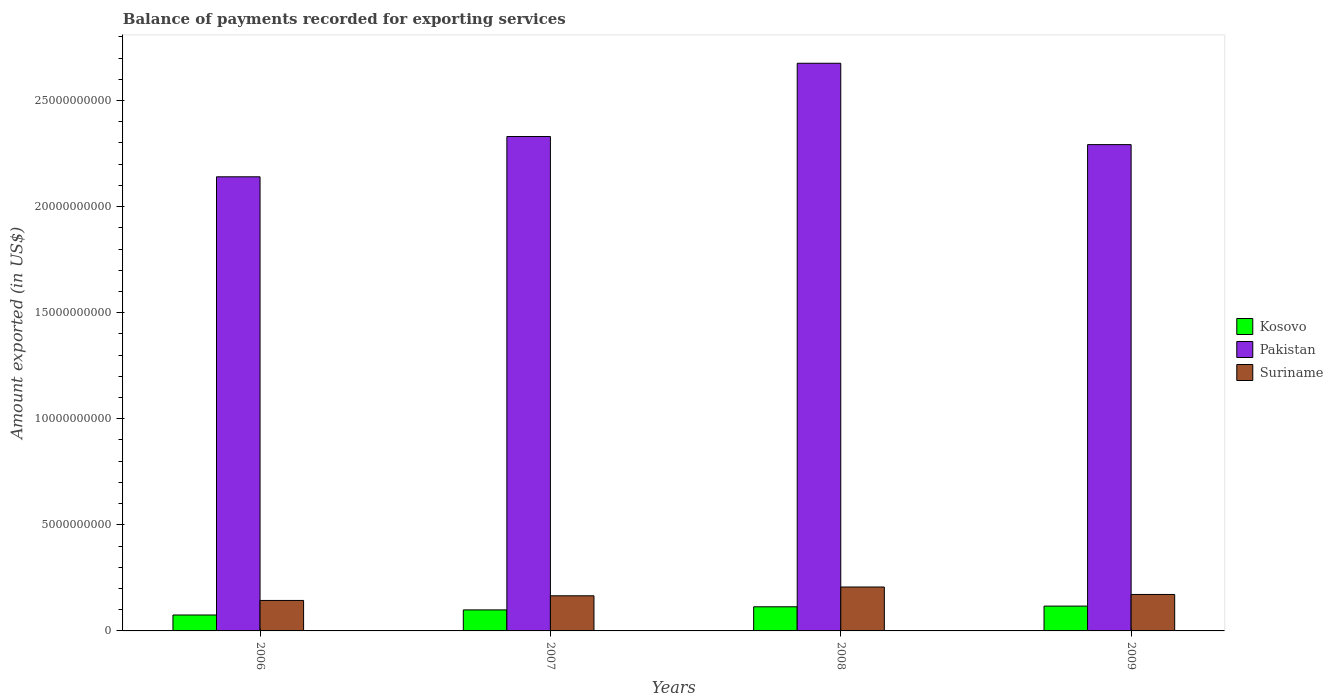Are the number of bars per tick equal to the number of legend labels?
Ensure brevity in your answer.  Yes. Are the number of bars on each tick of the X-axis equal?
Your answer should be compact. Yes. How many bars are there on the 4th tick from the right?
Your answer should be compact. 3. What is the amount exported in Kosovo in 2007?
Keep it short and to the point. 9.91e+08. Across all years, what is the maximum amount exported in Kosovo?
Give a very brief answer. 1.17e+09. Across all years, what is the minimum amount exported in Suriname?
Your response must be concise. 1.44e+09. What is the total amount exported in Kosovo in the graph?
Ensure brevity in your answer.  4.05e+09. What is the difference between the amount exported in Kosovo in 2008 and that in 2009?
Provide a short and direct response. -3.21e+07. What is the difference between the amount exported in Suriname in 2008 and the amount exported in Pakistan in 2006?
Provide a succinct answer. -1.93e+1. What is the average amount exported in Kosovo per year?
Give a very brief answer. 1.01e+09. In the year 2008, what is the difference between the amount exported in Kosovo and amount exported in Pakistan?
Provide a short and direct response. -2.56e+1. In how many years, is the amount exported in Pakistan greater than 1000000000 US$?
Offer a very short reply. 4. What is the ratio of the amount exported in Pakistan in 2007 to that in 2009?
Ensure brevity in your answer.  1.02. Is the difference between the amount exported in Kosovo in 2008 and 2009 greater than the difference between the amount exported in Pakistan in 2008 and 2009?
Your response must be concise. No. What is the difference between the highest and the second highest amount exported in Pakistan?
Keep it short and to the point. 3.45e+09. What is the difference between the highest and the lowest amount exported in Kosovo?
Provide a succinct answer. 4.19e+08. In how many years, is the amount exported in Pakistan greater than the average amount exported in Pakistan taken over all years?
Offer a terse response. 1. Is the sum of the amount exported in Suriname in 2007 and 2008 greater than the maximum amount exported in Pakistan across all years?
Your response must be concise. No. What does the 3rd bar from the left in 2009 represents?
Make the answer very short. Suriname. What does the 3rd bar from the right in 2008 represents?
Your answer should be compact. Kosovo. Is it the case that in every year, the sum of the amount exported in Suriname and amount exported in Pakistan is greater than the amount exported in Kosovo?
Give a very brief answer. Yes. Are all the bars in the graph horizontal?
Give a very brief answer. No. Are the values on the major ticks of Y-axis written in scientific E-notation?
Provide a succinct answer. No. How are the legend labels stacked?
Offer a terse response. Vertical. What is the title of the graph?
Provide a short and direct response. Balance of payments recorded for exporting services. Does "Panama" appear as one of the legend labels in the graph?
Give a very brief answer. No. What is the label or title of the X-axis?
Your response must be concise. Years. What is the label or title of the Y-axis?
Your response must be concise. Amount exported (in US$). What is the Amount exported (in US$) of Kosovo in 2006?
Offer a very short reply. 7.50e+08. What is the Amount exported (in US$) of Pakistan in 2006?
Offer a very short reply. 2.14e+1. What is the Amount exported (in US$) of Suriname in 2006?
Offer a very short reply. 1.44e+09. What is the Amount exported (in US$) of Kosovo in 2007?
Provide a short and direct response. 9.91e+08. What is the Amount exported (in US$) in Pakistan in 2007?
Make the answer very short. 2.33e+1. What is the Amount exported (in US$) of Suriname in 2007?
Keep it short and to the point. 1.66e+09. What is the Amount exported (in US$) of Kosovo in 2008?
Keep it short and to the point. 1.14e+09. What is the Amount exported (in US$) of Pakistan in 2008?
Ensure brevity in your answer.  2.68e+1. What is the Amount exported (in US$) of Suriname in 2008?
Your response must be concise. 2.07e+09. What is the Amount exported (in US$) of Kosovo in 2009?
Provide a succinct answer. 1.17e+09. What is the Amount exported (in US$) of Pakistan in 2009?
Keep it short and to the point. 2.29e+1. What is the Amount exported (in US$) in Suriname in 2009?
Provide a short and direct response. 1.72e+09. Across all years, what is the maximum Amount exported (in US$) of Kosovo?
Give a very brief answer. 1.17e+09. Across all years, what is the maximum Amount exported (in US$) in Pakistan?
Your answer should be very brief. 2.68e+1. Across all years, what is the maximum Amount exported (in US$) in Suriname?
Make the answer very short. 2.07e+09. Across all years, what is the minimum Amount exported (in US$) in Kosovo?
Keep it short and to the point. 7.50e+08. Across all years, what is the minimum Amount exported (in US$) in Pakistan?
Provide a succinct answer. 2.14e+1. Across all years, what is the minimum Amount exported (in US$) of Suriname?
Make the answer very short. 1.44e+09. What is the total Amount exported (in US$) of Kosovo in the graph?
Give a very brief answer. 4.05e+09. What is the total Amount exported (in US$) of Pakistan in the graph?
Give a very brief answer. 9.44e+1. What is the total Amount exported (in US$) of Suriname in the graph?
Ensure brevity in your answer.  6.88e+09. What is the difference between the Amount exported (in US$) of Kosovo in 2006 and that in 2007?
Offer a terse response. -2.40e+08. What is the difference between the Amount exported (in US$) in Pakistan in 2006 and that in 2007?
Offer a terse response. -1.90e+09. What is the difference between the Amount exported (in US$) of Suriname in 2006 and that in 2007?
Ensure brevity in your answer.  -2.20e+08. What is the difference between the Amount exported (in US$) in Kosovo in 2006 and that in 2008?
Provide a succinct answer. -3.87e+08. What is the difference between the Amount exported (in US$) of Pakistan in 2006 and that in 2008?
Your answer should be very brief. -5.35e+09. What is the difference between the Amount exported (in US$) in Suriname in 2006 and that in 2008?
Offer a very short reply. -6.34e+08. What is the difference between the Amount exported (in US$) in Kosovo in 2006 and that in 2009?
Keep it short and to the point. -4.19e+08. What is the difference between the Amount exported (in US$) of Pakistan in 2006 and that in 2009?
Offer a terse response. -1.52e+09. What is the difference between the Amount exported (in US$) of Suriname in 2006 and that in 2009?
Offer a very short reply. -2.82e+08. What is the difference between the Amount exported (in US$) of Kosovo in 2007 and that in 2008?
Your answer should be very brief. -1.47e+08. What is the difference between the Amount exported (in US$) in Pakistan in 2007 and that in 2008?
Keep it short and to the point. -3.45e+09. What is the difference between the Amount exported (in US$) of Suriname in 2007 and that in 2008?
Make the answer very short. -4.14e+08. What is the difference between the Amount exported (in US$) of Kosovo in 2007 and that in 2009?
Your response must be concise. -1.79e+08. What is the difference between the Amount exported (in US$) in Pakistan in 2007 and that in 2009?
Your response must be concise. 3.81e+08. What is the difference between the Amount exported (in US$) in Suriname in 2007 and that in 2009?
Provide a succinct answer. -6.23e+07. What is the difference between the Amount exported (in US$) in Kosovo in 2008 and that in 2009?
Give a very brief answer. -3.21e+07. What is the difference between the Amount exported (in US$) of Pakistan in 2008 and that in 2009?
Your answer should be very brief. 3.83e+09. What is the difference between the Amount exported (in US$) of Suriname in 2008 and that in 2009?
Your answer should be compact. 3.52e+08. What is the difference between the Amount exported (in US$) of Kosovo in 2006 and the Amount exported (in US$) of Pakistan in 2007?
Make the answer very short. -2.26e+1. What is the difference between the Amount exported (in US$) in Kosovo in 2006 and the Amount exported (in US$) in Suriname in 2007?
Offer a very short reply. -9.06e+08. What is the difference between the Amount exported (in US$) of Pakistan in 2006 and the Amount exported (in US$) of Suriname in 2007?
Provide a succinct answer. 1.97e+1. What is the difference between the Amount exported (in US$) of Kosovo in 2006 and the Amount exported (in US$) of Pakistan in 2008?
Ensure brevity in your answer.  -2.60e+1. What is the difference between the Amount exported (in US$) in Kosovo in 2006 and the Amount exported (in US$) in Suriname in 2008?
Keep it short and to the point. -1.32e+09. What is the difference between the Amount exported (in US$) in Pakistan in 2006 and the Amount exported (in US$) in Suriname in 2008?
Ensure brevity in your answer.  1.93e+1. What is the difference between the Amount exported (in US$) in Kosovo in 2006 and the Amount exported (in US$) in Pakistan in 2009?
Provide a short and direct response. -2.22e+1. What is the difference between the Amount exported (in US$) of Kosovo in 2006 and the Amount exported (in US$) of Suriname in 2009?
Give a very brief answer. -9.68e+08. What is the difference between the Amount exported (in US$) of Pakistan in 2006 and the Amount exported (in US$) of Suriname in 2009?
Give a very brief answer. 1.97e+1. What is the difference between the Amount exported (in US$) of Kosovo in 2007 and the Amount exported (in US$) of Pakistan in 2008?
Provide a short and direct response. -2.58e+1. What is the difference between the Amount exported (in US$) of Kosovo in 2007 and the Amount exported (in US$) of Suriname in 2008?
Make the answer very short. -1.08e+09. What is the difference between the Amount exported (in US$) of Pakistan in 2007 and the Amount exported (in US$) of Suriname in 2008?
Give a very brief answer. 2.12e+1. What is the difference between the Amount exported (in US$) of Kosovo in 2007 and the Amount exported (in US$) of Pakistan in 2009?
Provide a short and direct response. -2.19e+1. What is the difference between the Amount exported (in US$) in Kosovo in 2007 and the Amount exported (in US$) in Suriname in 2009?
Keep it short and to the point. -7.28e+08. What is the difference between the Amount exported (in US$) in Pakistan in 2007 and the Amount exported (in US$) in Suriname in 2009?
Offer a terse response. 2.16e+1. What is the difference between the Amount exported (in US$) in Kosovo in 2008 and the Amount exported (in US$) in Pakistan in 2009?
Offer a very short reply. -2.18e+1. What is the difference between the Amount exported (in US$) of Kosovo in 2008 and the Amount exported (in US$) of Suriname in 2009?
Your answer should be very brief. -5.81e+08. What is the difference between the Amount exported (in US$) in Pakistan in 2008 and the Amount exported (in US$) in Suriname in 2009?
Your answer should be compact. 2.50e+1. What is the average Amount exported (in US$) in Kosovo per year?
Offer a very short reply. 1.01e+09. What is the average Amount exported (in US$) of Pakistan per year?
Your answer should be compact. 2.36e+1. What is the average Amount exported (in US$) in Suriname per year?
Offer a terse response. 1.72e+09. In the year 2006, what is the difference between the Amount exported (in US$) of Kosovo and Amount exported (in US$) of Pakistan?
Make the answer very short. -2.07e+1. In the year 2006, what is the difference between the Amount exported (in US$) of Kosovo and Amount exported (in US$) of Suriname?
Offer a terse response. -6.86e+08. In the year 2006, what is the difference between the Amount exported (in US$) of Pakistan and Amount exported (in US$) of Suriname?
Provide a short and direct response. 2.00e+1. In the year 2007, what is the difference between the Amount exported (in US$) of Kosovo and Amount exported (in US$) of Pakistan?
Your answer should be compact. -2.23e+1. In the year 2007, what is the difference between the Amount exported (in US$) in Kosovo and Amount exported (in US$) in Suriname?
Ensure brevity in your answer.  -6.65e+08. In the year 2007, what is the difference between the Amount exported (in US$) of Pakistan and Amount exported (in US$) of Suriname?
Ensure brevity in your answer.  2.16e+1. In the year 2008, what is the difference between the Amount exported (in US$) in Kosovo and Amount exported (in US$) in Pakistan?
Ensure brevity in your answer.  -2.56e+1. In the year 2008, what is the difference between the Amount exported (in US$) of Kosovo and Amount exported (in US$) of Suriname?
Your answer should be compact. -9.32e+08. In the year 2008, what is the difference between the Amount exported (in US$) of Pakistan and Amount exported (in US$) of Suriname?
Offer a very short reply. 2.47e+1. In the year 2009, what is the difference between the Amount exported (in US$) in Kosovo and Amount exported (in US$) in Pakistan?
Make the answer very short. -2.18e+1. In the year 2009, what is the difference between the Amount exported (in US$) of Kosovo and Amount exported (in US$) of Suriname?
Offer a very short reply. -5.48e+08. In the year 2009, what is the difference between the Amount exported (in US$) of Pakistan and Amount exported (in US$) of Suriname?
Keep it short and to the point. 2.12e+1. What is the ratio of the Amount exported (in US$) of Kosovo in 2006 to that in 2007?
Make the answer very short. 0.76. What is the ratio of the Amount exported (in US$) in Pakistan in 2006 to that in 2007?
Your answer should be very brief. 0.92. What is the ratio of the Amount exported (in US$) of Suriname in 2006 to that in 2007?
Ensure brevity in your answer.  0.87. What is the ratio of the Amount exported (in US$) of Kosovo in 2006 to that in 2008?
Your answer should be very brief. 0.66. What is the ratio of the Amount exported (in US$) of Pakistan in 2006 to that in 2008?
Offer a very short reply. 0.8. What is the ratio of the Amount exported (in US$) in Suriname in 2006 to that in 2008?
Keep it short and to the point. 0.69. What is the ratio of the Amount exported (in US$) in Kosovo in 2006 to that in 2009?
Offer a very short reply. 0.64. What is the ratio of the Amount exported (in US$) in Pakistan in 2006 to that in 2009?
Make the answer very short. 0.93. What is the ratio of the Amount exported (in US$) of Suriname in 2006 to that in 2009?
Your answer should be compact. 0.84. What is the ratio of the Amount exported (in US$) of Kosovo in 2007 to that in 2008?
Offer a very short reply. 0.87. What is the ratio of the Amount exported (in US$) of Pakistan in 2007 to that in 2008?
Provide a succinct answer. 0.87. What is the ratio of the Amount exported (in US$) of Suriname in 2007 to that in 2008?
Provide a short and direct response. 0.8. What is the ratio of the Amount exported (in US$) of Kosovo in 2007 to that in 2009?
Provide a short and direct response. 0.85. What is the ratio of the Amount exported (in US$) of Pakistan in 2007 to that in 2009?
Offer a terse response. 1.02. What is the ratio of the Amount exported (in US$) of Suriname in 2007 to that in 2009?
Your answer should be very brief. 0.96. What is the ratio of the Amount exported (in US$) of Kosovo in 2008 to that in 2009?
Provide a short and direct response. 0.97. What is the ratio of the Amount exported (in US$) in Pakistan in 2008 to that in 2009?
Your answer should be very brief. 1.17. What is the ratio of the Amount exported (in US$) of Suriname in 2008 to that in 2009?
Offer a terse response. 1.2. What is the difference between the highest and the second highest Amount exported (in US$) in Kosovo?
Your answer should be compact. 3.21e+07. What is the difference between the highest and the second highest Amount exported (in US$) in Pakistan?
Offer a very short reply. 3.45e+09. What is the difference between the highest and the second highest Amount exported (in US$) in Suriname?
Ensure brevity in your answer.  3.52e+08. What is the difference between the highest and the lowest Amount exported (in US$) in Kosovo?
Your response must be concise. 4.19e+08. What is the difference between the highest and the lowest Amount exported (in US$) in Pakistan?
Make the answer very short. 5.35e+09. What is the difference between the highest and the lowest Amount exported (in US$) of Suriname?
Keep it short and to the point. 6.34e+08. 